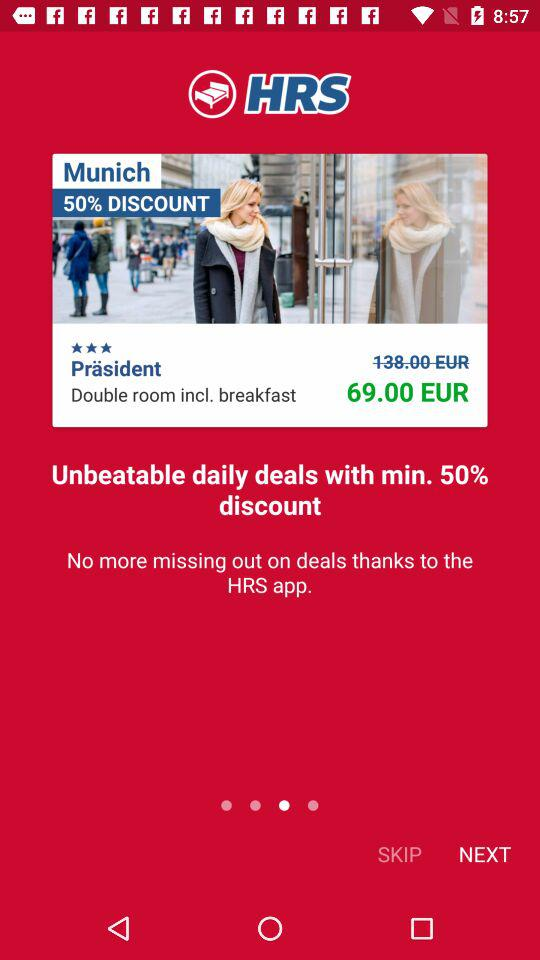What is the mentioned place name? The mentioned place name is Munich. 